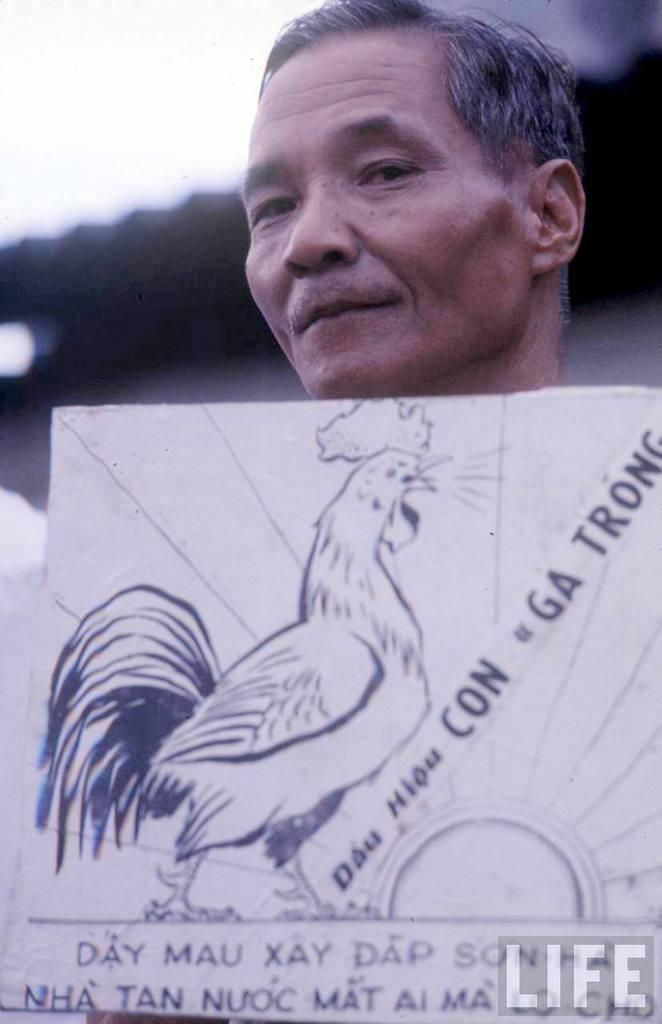Who is the main subject in the image? There is an old man in the image. What is located at the bottom of the image? There is a board at the bottom of the image. What can be seen on the board? There is text on the board and a hen sketch. How would you describe the background of the image? The background of the image has a blurred view. How much wealth does the old man have in the image? There is no information about the old man's wealth in the image. What type of nail is being used to adjust the board in the image? There is no nail or adjustment being made to the board in the image. 